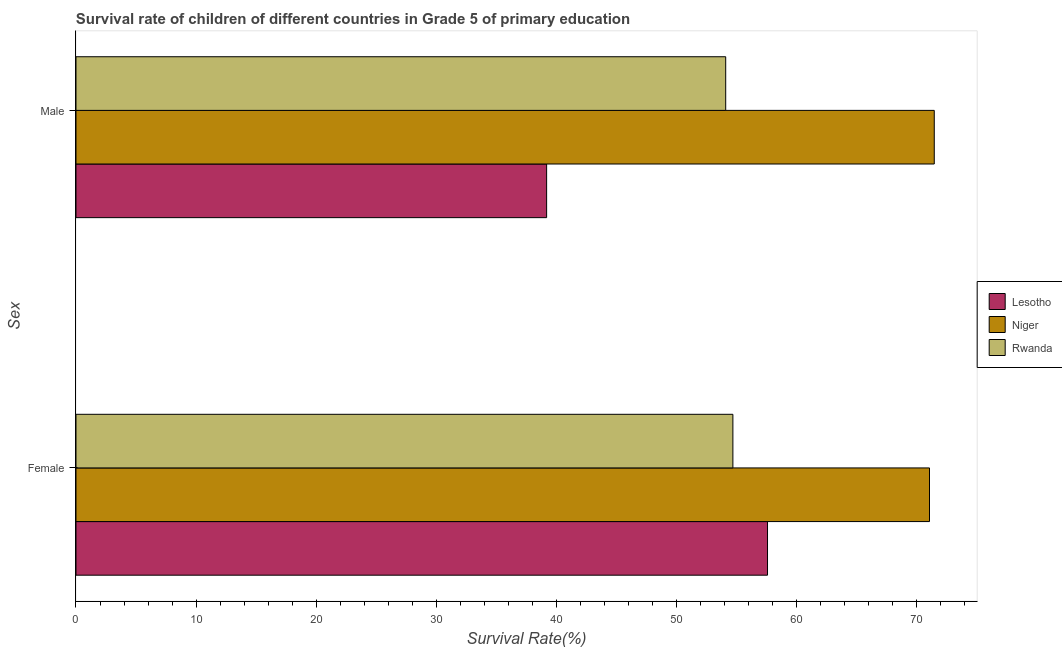How many groups of bars are there?
Your response must be concise. 2. Are the number of bars on each tick of the Y-axis equal?
Make the answer very short. Yes. What is the survival rate of male students in primary education in Rwanda?
Your response must be concise. 54.11. Across all countries, what is the maximum survival rate of male students in primary education?
Keep it short and to the point. 71.47. Across all countries, what is the minimum survival rate of female students in primary education?
Offer a terse response. 54.7. In which country was the survival rate of female students in primary education maximum?
Offer a very short reply. Niger. In which country was the survival rate of male students in primary education minimum?
Offer a terse response. Lesotho. What is the total survival rate of female students in primary education in the graph?
Provide a short and direct response. 183.37. What is the difference between the survival rate of female students in primary education in Lesotho and that in Rwanda?
Give a very brief answer. 2.88. What is the difference between the survival rate of male students in primary education in Lesotho and the survival rate of female students in primary education in Rwanda?
Make the answer very short. -15.51. What is the average survival rate of female students in primary education per country?
Offer a very short reply. 61.12. What is the difference between the survival rate of female students in primary education and survival rate of male students in primary education in Lesotho?
Provide a short and direct response. 18.39. In how many countries, is the survival rate of male students in primary education greater than 42 %?
Offer a very short reply. 2. What is the ratio of the survival rate of female students in primary education in Niger to that in Rwanda?
Your answer should be compact. 1.3. What does the 1st bar from the top in Male represents?
Ensure brevity in your answer.  Rwanda. What does the 2nd bar from the bottom in Female represents?
Offer a terse response. Niger. Are the values on the major ticks of X-axis written in scientific E-notation?
Offer a very short reply. No. How are the legend labels stacked?
Provide a short and direct response. Vertical. What is the title of the graph?
Your answer should be compact. Survival rate of children of different countries in Grade 5 of primary education. What is the label or title of the X-axis?
Offer a terse response. Survival Rate(%). What is the label or title of the Y-axis?
Your answer should be very brief. Sex. What is the Survival Rate(%) in Lesotho in Female?
Make the answer very short. 57.59. What is the Survival Rate(%) of Niger in Female?
Give a very brief answer. 71.08. What is the Survival Rate(%) of Rwanda in Female?
Provide a succinct answer. 54.7. What is the Survival Rate(%) in Lesotho in Male?
Your answer should be compact. 39.19. What is the Survival Rate(%) in Niger in Male?
Provide a succinct answer. 71.47. What is the Survival Rate(%) of Rwanda in Male?
Your response must be concise. 54.11. Across all Sex, what is the maximum Survival Rate(%) of Lesotho?
Offer a very short reply. 57.59. Across all Sex, what is the maximum Survival Rate(%) in Niger?
Provide a succinct answer. 71.47. Across all Sex, what is the maximum Survival Rate(%) in Rwanda?
Your answer should be very brief. 54.7. Across all Sex, what is the minimum Survival Rate(%) of Lesotho?
Offer a terse response. 39.19. Across all Sex, what is the minimum Survival Rate(%) in Niger?
Give a very brief answer. 71.08. Across all Sex, what is the minimum Survival Rate(%) in Rwanda?
Your answer should be very brief. 54.11. What is the total Survival Rate(%) in Lesotho in the graph?
Your response must be concise. 96.78. What is the total Survival Rate(%) of Niger in the graph?
Provide a short and direct response. 142.55. What is the total Survival Rate(%) of Rwanda in the graph?
Your answer should be compact. 108.81. What is the difference between the Survival Rate(%) in Lesotho in Female and that in Male?
Provide a short and direct response. 18.39. What is the difference between the Survival Rate(%) of Niger in Female and that in Male?
Provide a succinct answer. -0.4. What is the difference between the Survival Rate(%) in Rwanda in Female and that in Male?
Your response must be concise. 0.6. What is the difference between the Survival Rate(%) in Lesotho in Female and the Survival Rate(%) in Niger in Male?
Make the answer very short. -13.89. What is the difference between the Survival Rate(%) in Lesotho in Female and the Survival Rate(%) in Rwanda in Male?
Provide a succinct answer. 3.48. What is the difference between the Survival Rate(%) of Niger in Female and the Survival Rate(%) of Rwanda in Male?
Provide a short and direct response. 16.97. What is the average Survival Rate(%) in Lesotho per Sex?
Make the answer very short. 48.39. What is the average Survival Rate(%) in Niger per Sex?
Give a very brief answer. 71.27. What is the average Survival Rate(%) of Rwanda per Sex?
Ensure brevity in your answer.  54.4. What is the difference between the Survival Rate(%) in Lesotho and Survival Rate(%) in Niger in Female?
Ensure brevity in your answer.  -13.49. What is the difference between the Survival Rate(%) of Lesotho and Survival Rate(%) of Rwanda in Female?
Your answer should be very brief. 2.88. What is the difference between the Survival Rate(%) of Niger and Survival Rate(%) of Rwanda in Female?
Provide a succinct answer. 16.37. What is the difference between the Survival Rate(%) of Lesotho and Survival Rate(%) of Niger in Male?
Your answer should be compact. -32.28. What is the difference between the Survival Rate(%) of Lesotho and Survival Rate(%) of Rwanda in Male?
Keep it short and to the point. -14.91. What is the difference between the Survival Rate(%) in Niger and Survival Rate(%) in Rwanda in Male?
Offer a very short reply. 17.37. What is the ratio of the Survival Rate(%) in Lesotho in Female to that in Male?
Offer a very short reply. 1.47. What is the ratio of the Survival Rate(%) in Rwanda in Female to that in Male?
Your answer should be compact. 1.01. What is the difference between the highest and the second highest Survival Rate(%) in Lesotho?
Make the answer very short. 18.39. What is the difference between the highest and the second highest Survival Rate(%) of Niger?
Offer a very short reply. 0.4. What is the difference between the highest and the second highest Survival Rate(%) of Rwanda?
Your response must be concise. 0.6. What is the difference between the highest and the lowest Survival Rate(%) in Lesotho?
Ensure brevity in your answer.  18.39. What is the difference between the highest and the lowest Survival Rate(%) in Niger?
Your answer should be very brief. 0.4. What is the difference between the highest and the lowest Survival Rate(%) of Rwanda?
Provide a succinct answer. 0.6. 